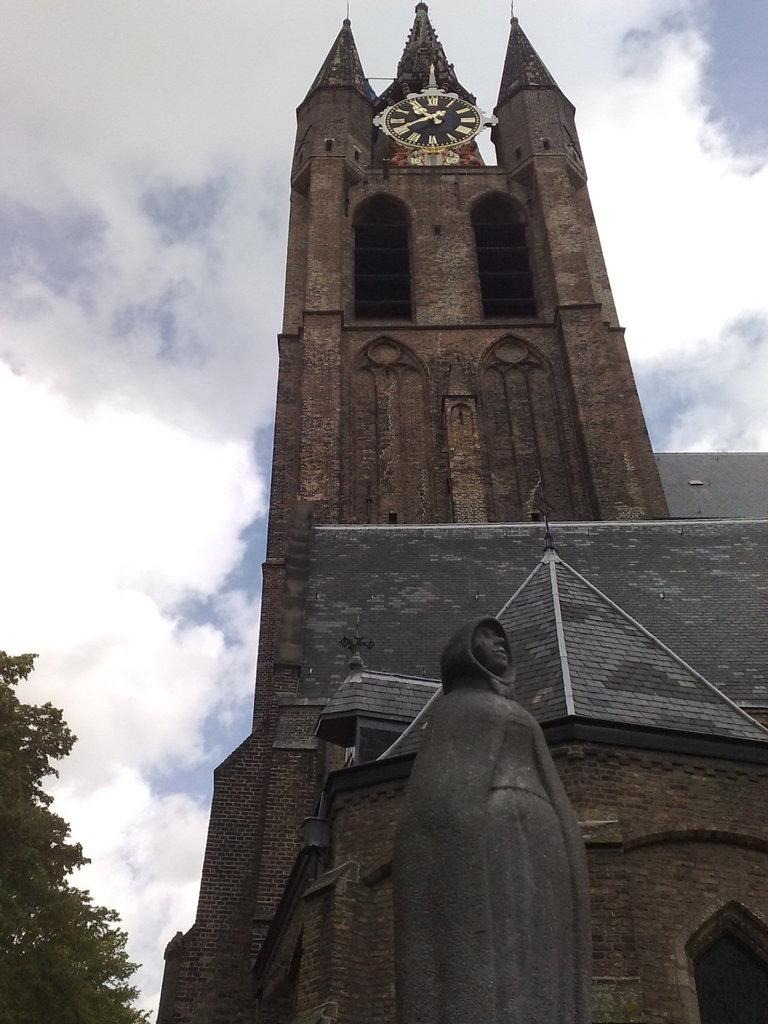What type of structure is visible in the image? There is a building in the image. What other object can be seen near the building? There is a statue in the image. What type of vegetation is present in the image? There are trees in the image. How would you describe the color of the sky in the image? The sky is blue and white in color. Can you identify any additional features on the building? Yes, a watch is attached to the building. What grade is the building in the image? The image does not provide information about the grade of the building. What scent can be detected from the trees in the image? The image does not provide information about the scent of the trees. 